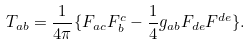<formula> <loc_0><loc_0><loc_500><loc_500>T _ { a b } = \frac { 1 } { 4 \pi } \{ F _ { a c } F _ { b } ^ { c } - \frac { 1 } { 4 } g _ { a b } F _ { d e } F ^ { d e } \} .</formula> 